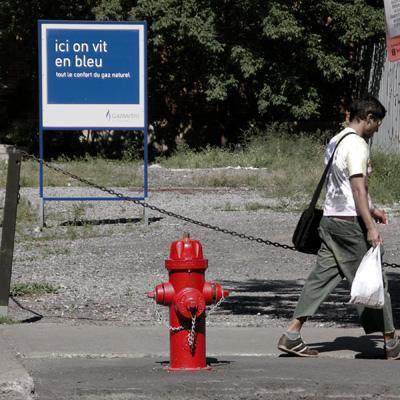How many bags is the man in the photograph carrying?
Answer briefly. 2. Is there a red fire hydrant in this photo?
Short answer required. Yes. Is the fire hydrant in this photo opened or closed?
Quick response, please. Closed. 